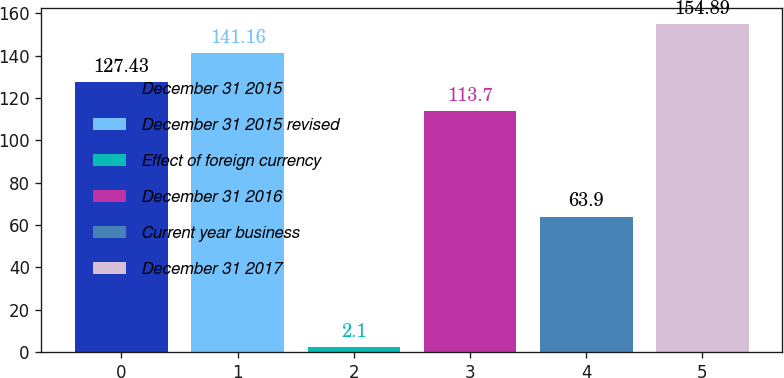Convert chart to OTSL. <chart><loc_0><loc_0><loc_500><loc_500><bar_chart><fcel>December 31 2015<fcel>December 31 2015 revised<fcel>Effect of foreign currency<fcel>December 31 2016<fcel>Current year business<fcel>December 31 2017<nl><fcel>127.43<fcel>141.16<fcel>2.1<fcel>113.7<fcel>63.9<fcel>154.89<nl></chart> 